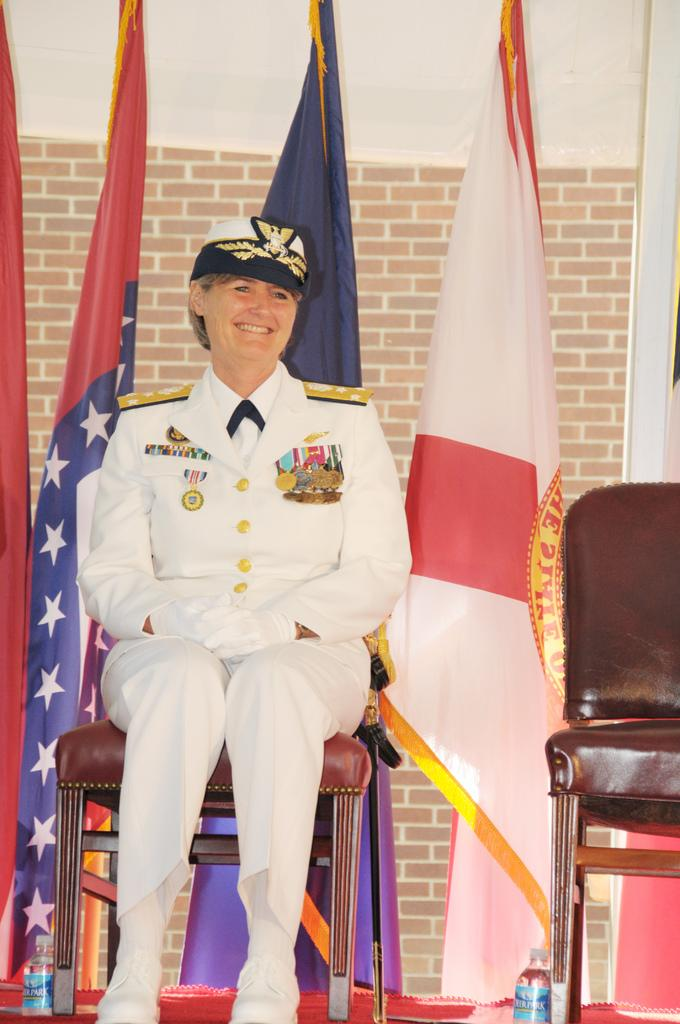Who is present in the image? There is a woman in the image. What is the woman doing in the image? The woman is sitting on a chair and smiling. How many chairs are visible in the image? There are two chairs in the image. What else can be seen in the image besides the chairs? There are 2 bottles and flags in the background of the image. What type of cloud is responsible for the friction between the sticks in the image? There are no clouds, sticks, or friction present in the image. 